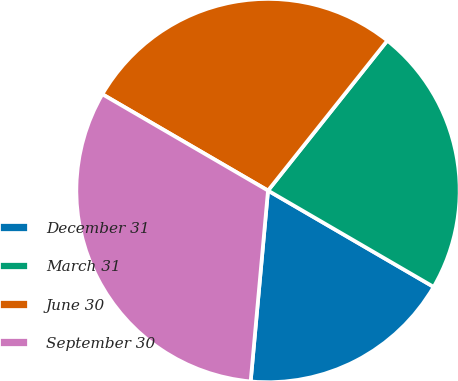Convert chart to OTSL. <chart><loc_0><loc_0><loc_500><loc_500><pie_chart><fcel>December 31<fcel>March 31<fcel>June 30<fcel>September 30<nl><fcel>18.06%<fcel>22.69%<fcel>27.31%<fcel>31.94%<nl></chart> 